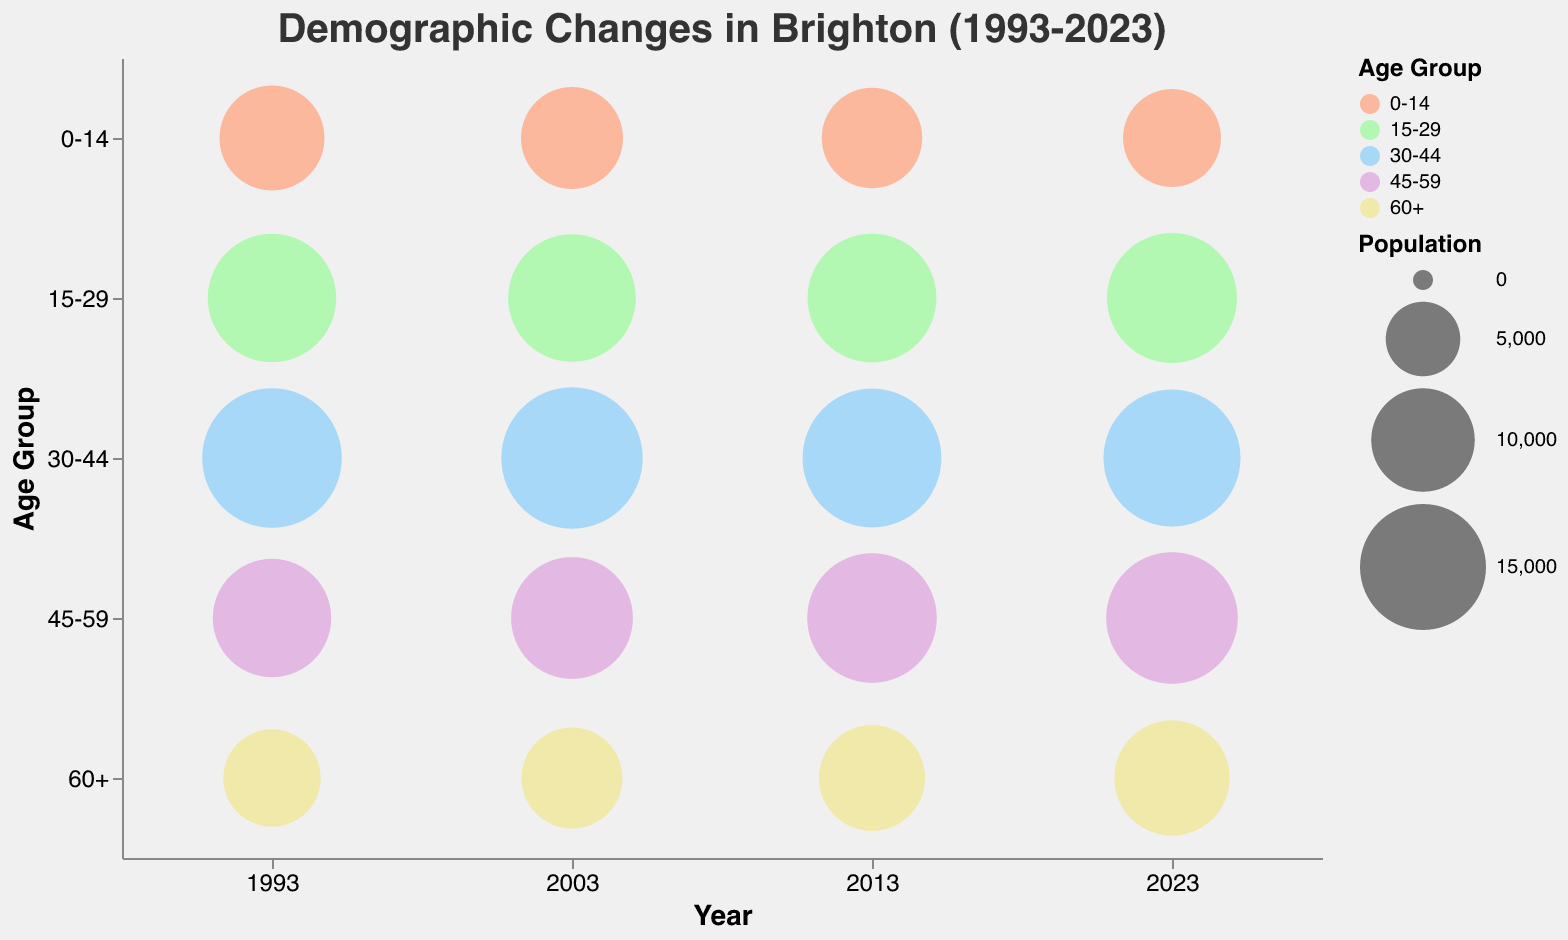What is the title of the chart? The title is located at the top of the chart and is typically the most prominent text. The title gives an overview of what the chart represents. In this case, the title is "Demographic Changes in Brighton (1993-2023)".
Answer: Demographic Changes in Brighton (1993-2023) Which age group had the largest population in 1993? To determine the largest population in 1993, locate the bubbles along the x-axis labeled "1993" and compare their sizes. The largest bubble represents the age group with the largest population. The age group "30-44" has the largest bubble.
Answer: 30-44 How has the population of the "60+" age group changed from 1993 to 2023? Compare the size of the bubbles for the "60+" age group in 1993 and 2023. The population has increased, as the bubble size in 2023 is larger than in 1993.
Answer: Increased Which year had the smallest population for the "0-14" age group? To find this, compare the size of the bubbles representing the "0-14" age group across all years (1993, 2003, 2013, 2023). The smallest bubble appears in the year 2023.
Answer: 2023 What is the trend in population for the "45-59" age group from 1993 to 2023? Observe the changes in bubble sizes for the "45-59" age group across the years. The population for this age group has increased, as seen by increasingly larger bubbles from 1993 to 2023.
Answer: Increased Which age group experienced the largest increase in population between 1993 and 2023? Compare the bubble size differences for each age group between the years 1993 and 2023. The "60+" age group shows the most significant increase in size, indicating the largest population increase.
Answer: 60+ What are the five different colors used to represent the age groups? Look at the color legend on the chart, which assigns a distinct color to each age group. The colors used are: light salmon (#FFA07A), pale green (#98FB98), sky blue (#87CEFA), plum (#DDA0DD), and khaki (#F0E68C).
Answer: light salmon, pale green, sky blue, plum, khaki What was the total population for all age groups in 2013? To find the total population in 2013, add the populations for all age groups: 9400 (0-14) + 15700 (15-29) + 18300 (30-44) + 15900 (45-59) + 10500 (60+). The sum is 69800.
Answer: 69800 